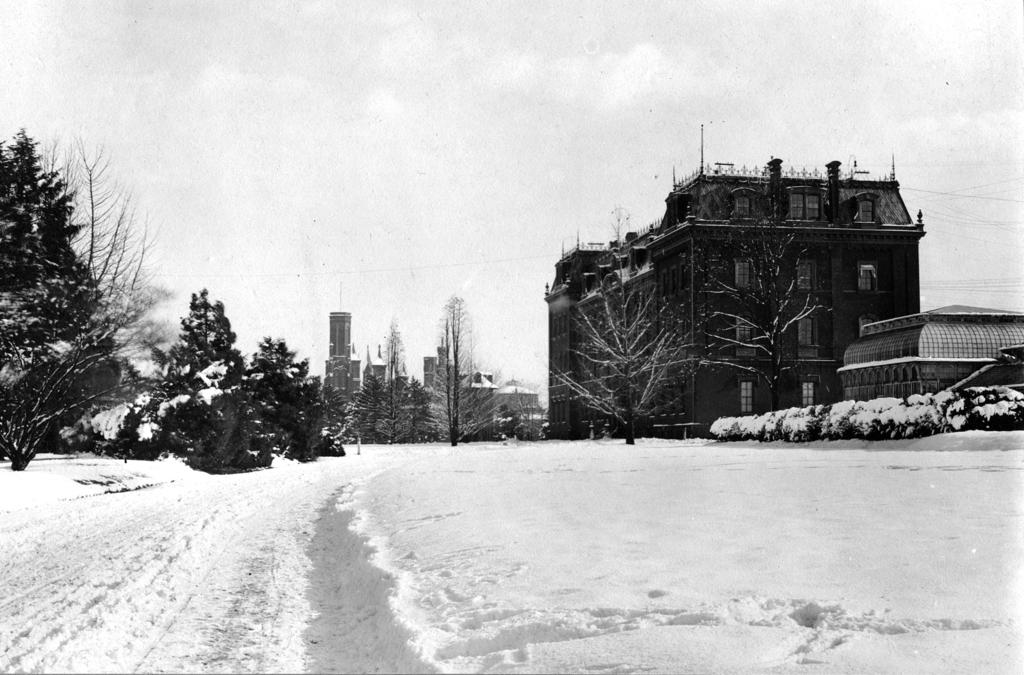What type of structures can be seen in the image? There are buildings in the image. What feature is visible on the buildings? There are windows visible in the image. What type of vegetation can be seen in the image? There are trees and dried trees in the image. What is the weather like in the image? There is snow visible in the image, indicating a cold climate. What is visible at the top of the image? The sky is visible at the top of the image. What type of shoe can be seen floating in a bubble in the image? There is no shoe or bubble present in the image. Is there a birthday celebration happening in the image? There is no indication of a birthday celebration in the image. 